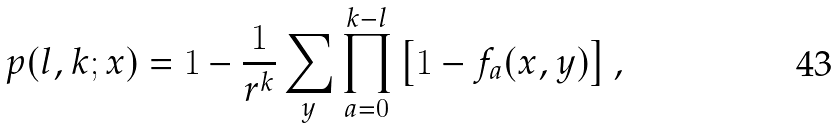<formula> <loc_0><loc_0><loc_500><loc_500>p ( l , k ; { x } ) = 1 - \frac { 1 } { r ^ { k } } \sum _ { y } \prod _ { a = 0 } ^ { k - l } \left [ 1 - f _ { a } ( { x } , { y } ) \right ] ,</formula> 